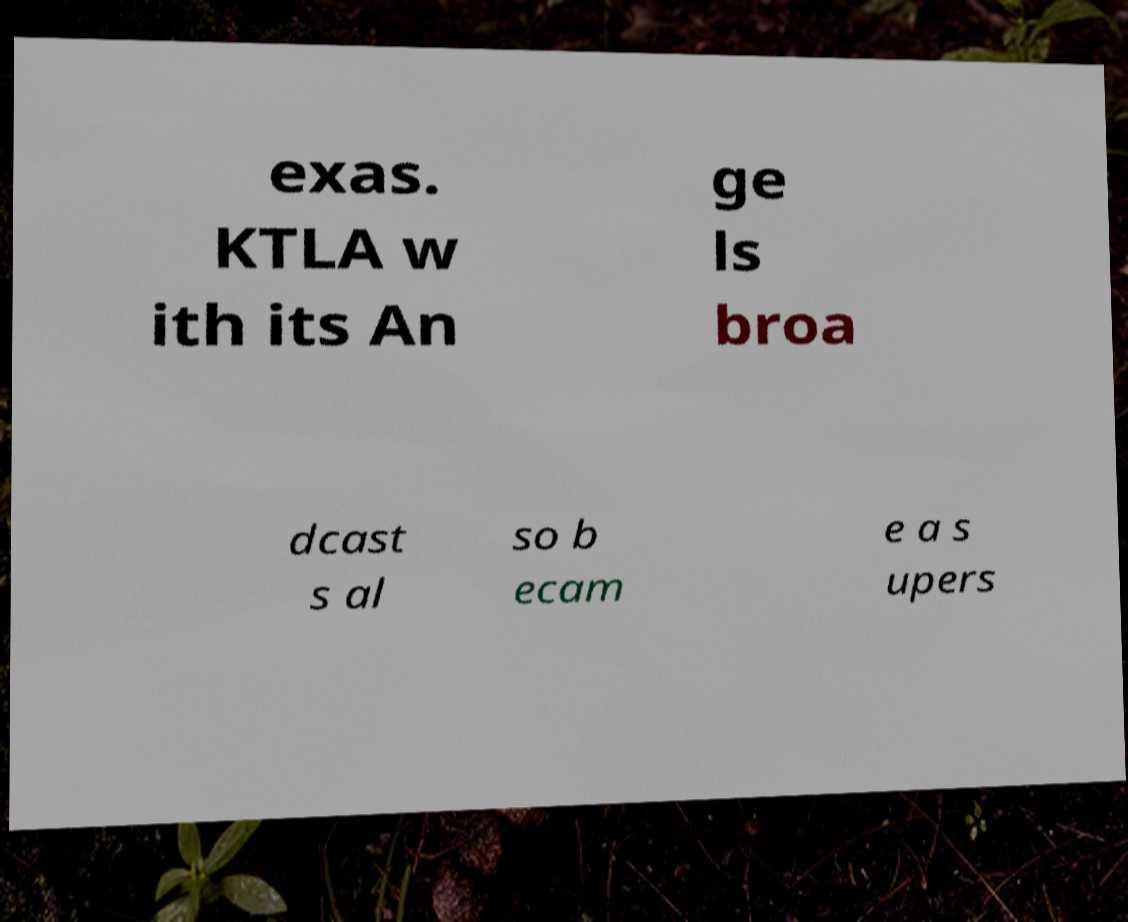There's text embedded in this image that I need extracted. Can you transcribe it verbatim? exas. KTLA w ith its An ge ls broa dcast s al so b ecam e a s upers 